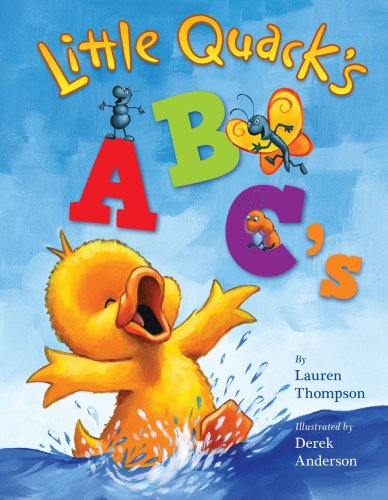What learning elements can be identified in this book based on the cover? Beyond the alphabetic elements indicated by 'ABC's' in the title, the cover features vibrant colors and playful characters, likely to attract and hold the interest of young readers, aiding in learning. Does the book incorporate any interactive elements or just visuals? While the cover suggests a focus on visuals, children's books often include rhymes or textured elements to engage different senses, though specifics would need to be confirmed by looking inside. 